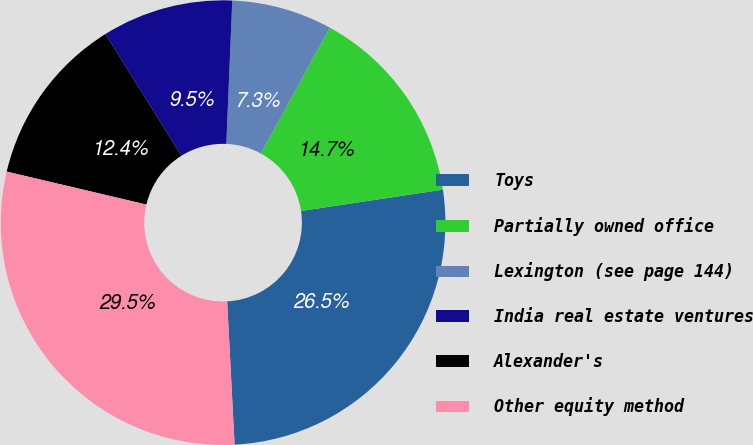<chart> <loc_0><loc_0><loc_500><loc_500><pie_chart><fcel>Toys<fcel>Partially owned office<fcel>Lexington (see page 144)<fcel>India real estate ventures<fcel>Alexander's<fcel>Other equity method<nl><fcel>26.55%<fcel>14.66%<fcel>7.31%<fcel>9.53%<fcel>12.44%<fcel>29.51%<nl></chart> 